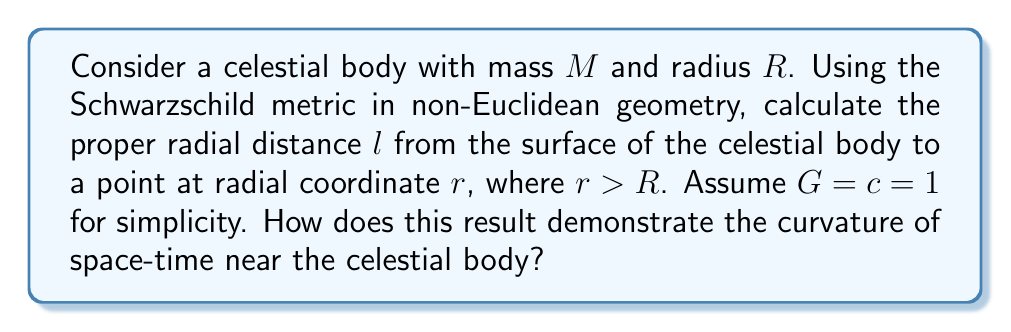Help me with this question. 1. The Schwarzschild metric in radial coordinates is given by:

   $$ds^2 = -\left(1 - \frac{2M}{r}\right)dt^2 + \frac{dr^2}{1 - \frac{2M}{r}} + r^2(d\theta^2 + \sin^2\theta d\phi^2)$$

2. For radial distances, we consider $dt = d\theta = d\phi = 0$, so:

   $$ds^2 = \frac{dr^2}{1 - \frac{2M}{r}}$$

3. The proper radial distance $l$ is obtained by integrating $ds$ from $R$ to $r$:

   $$l = \int_R^r \frac{dr'}{\sqrt{1 - \frac{2M}{r'}}}$$

4. This integral can be solved analytically:

   $$l = \sqrt{r(r-2M)} + M\ln\left(\frac{r-M+\sqrt{r(r-2M)}}{M}\right) - \sqrt{R(R-2M)} - M\ln\left(\frac{R-M+\sqrt{R(R-2M)}}{M}\right)$$

5. In Euclidean geometry, the radial distance would simply be $r - R$. The difference between $l$ and $r - R$ demonstrates the curvature of space-time.

6. As $r$ approaches infinity, $l$ grows more slowly than $r - R$, indicating that space is "stretched" near the celestial body.

7. This curvature becomes more pronounced as $M$ increases or as we approach the Schwarzschild radius ($r = 2M$), where the expression diverges, representing the event horizon of a black hole.

8. From a theological perspective, this mathematical description of space-time curvature can be seen as a reflection of the divine order and complexity in God's creation, demonstrating how the fabric of the universe bends in the presence of massive celestial bodies.
Answer: $l = \sqrt{r(r-2M)} + M\ln\left(\frac{r-M+\sqrt{r(r-2M)}}{M}\right) - \sqrt{R(R-2M)} - M\ln\left(\frac{R-M+\sqrt{R(R-2M)}}{M}\right)$ 